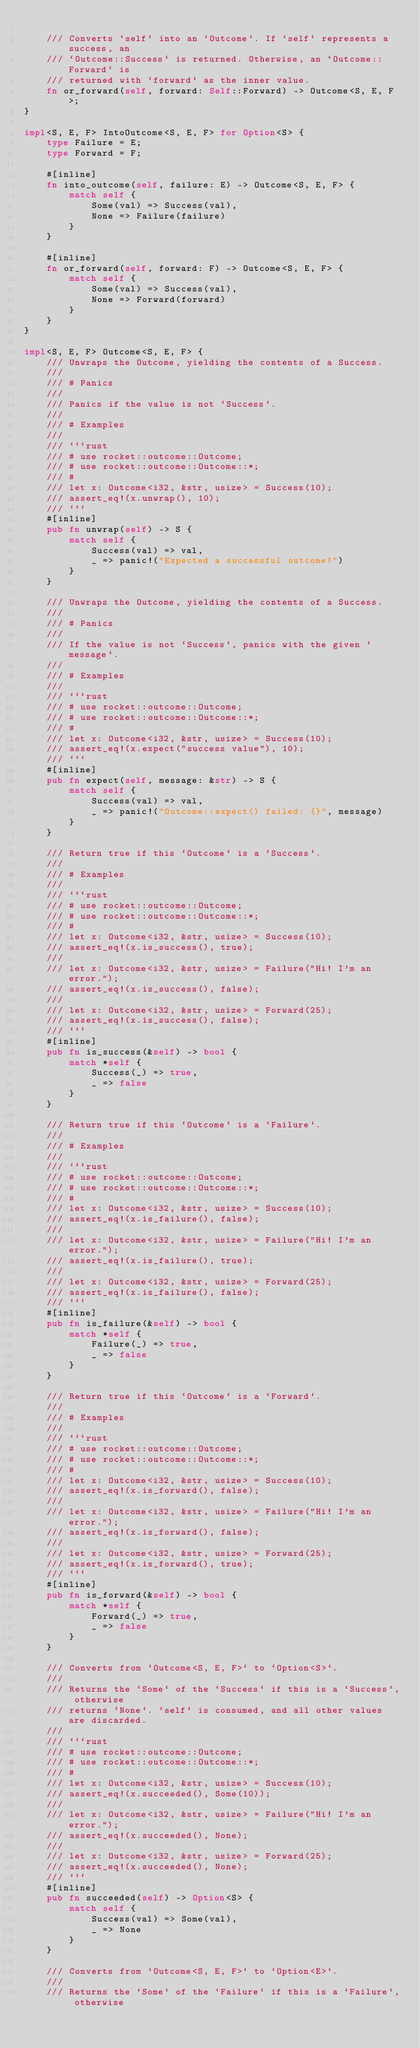Convert code to text. <code><loc_0><loc_0><loc_500><loc_500><_Rust_>
    /// Converts `self` into an `Outcome`. If `self` represents a success, an
    /// `Outcome::Success` is returned. Otherwise, an `Outcome::Forward` is
    /// returned with `forward` as the inner value.
    fn or_forward(self, forward: Self::Forward) -> Outcome<S, E, F>;
}

impl<S, E, F> IntoOutcome<S, E, F> for Option<S> {
    type Failure = E;
    type Forward = F;

    #[inline]
    fn into_outcome(self, failure: E) -> Outcome<S, E, F> {
        match self {
            Some(val) => Success(val),
            None => Failure(failure)
        }
    }

    #[inline]
    fn or_forward(self, forward: F) -> Outcome<S, E, F> {
        match self {
            Some(val) => Success(val),
            None => Forward(forward)
        }
    }
}

impl<S, E, F> Outcome<S, E, F> {
    /// Unwraps the Outcome, yielding the contents of a Success.
    ///
    /// # Panics
    ///
    /// Panics if the value is not `Success`.
    ///
    /// # Examples
    ///
    /// ```rust
    /// # use rocket::outcome::Outcome;
    /// # use rocket::outcome::Outcome::*;
    /// #
    /// let x: Outcome<i32, &str, usize> = Success(10);
    /// assert_eq!(x.unwrap(), 10);
    /// ```
    #[inline]
    pub fn unwrap(self) -> S {
        match self {
            Success(val) => val,
            _ => panic!("Expected a successful outcome!")
        }
    }

    /// Unwraps the Outcome, yielding the contents of a Success.
    ///
    /// # Panics
    ///
    /// If the value is not `Success`, panics with the given `message`.
    ///
    /// # Examples
    ///
    /// ```rust
    /// # use rocket::outcome::Outcome;
    /// # use rocket::outcome::Outcome::*;
    /// #
    /// let x: Outcome<i32, &str, usize> = Success(10);
    /// assert_eq!(x.expect("success value"), 10);
    /// ```
    #[inline]
    pub fn expect(self, message: &str) -> S {
        match self {
            Success(val) => val,
            _ => panic!("Outcome::expect() failed: {}", message)
        }
    }

    /// Return true if this `Outcome` is a `Success`.
    ///
    /// # Examples
    ///
    /// ```rust
    /// # use rocket::outcome::Outcome;
    /// # use rocket::outcome::Outcome::*;
    /// #
    /// let x: Outcome<i32, &str, usize> = Success(10);
    /// assert_eq!(x.is_success(), true);
    ///
    /// let x: Outcome<i32, &str, usize> = Failure("Hi! I'm an error.");
    /// assert_eq!(x.is_success(), false);
    ///
    /// let x: Outcome<i32, &str, usize> = Forward(25);
    /// assert_eq!(x.is_success(), false);
    /// ```
    #[inline]
    pub fn is_success(&self) -> bool {
        match *self {
            Success(_) => true,
            _ => false
        }
    }

    /// Return true if this `Outcome` is a `Failure`.
    ///
    /// # Examples
    ///
    /// ```rust
    /// # use rocket::outcome::Outcome;
    /// # use rocket::outcome::Outcome::*;
    /// #
    /// let x: Outcome<i32, &str, usize> = Success(10);
    /// assert_eq!(x.is_failure(), false);
    ///
    /// let x: Outcome<i32, &str, usize> = Failure("Hi! I'm an error.");
    /// assert_eq!(x.is_failure(), true);
    ///
    /// let x: Outcome<i32, &str, usize> = Forward(25);
    /// assert_eq!(x.is_failure(), false);
    /// ```
    #[inline]
    pub fn is_failure(&self) -> bool {
        match *self {
            Failure(_) => true,
            _ => false
        }
    }

    /// Return true if this `Outcome` is a `Forward`.
    ///
    /// # Examples
    ///
    /// ```rust
    /// # use rocket::outcome::Outcome;
    /// # use rocket::outcome::Outcome::*;
    /// #
    /// let x: Outcome<i32, &str, usize> = Success(10);
    /// assert_eq!(x.is_forward(), false);
    ///
    /// let x: Outcome<i32, &str, usize> = Failure("Hi! I'm an error.");
    /// assert_eq!(x.is_forward(), false);
    ///
    /// let x: Outcome<i32, &str, usize> = Forward(25);
    /// assert_eq!(x.is_forward(), true);
    /// ```
    #[inline]
    pub fn is_forward(&self) -> bool {
        match *self {
            Forward(_) => true,
            _ => false
        }
    }

    /// Converts from `Outcome<S, E, F>` to `Option<S>`.
    ///
    /// Returns the `Some` of the `Success` if this is a `Success`, otherwise
    /// returns `None`. `self` is consumed, and all other values are discarded.
    ///
    /// ```rust
    /// # use rocket::outcome::Outcome;
    /// # use rocket::outcome::Outcome::*;
    /// #
    /// let x: Outcome<i32, &str, usize> = Success(10);
    /// assert_eq!(x.succeeded(), Some(10));
    ///
    /// let x: Outcome<i32, &str, usize> = Failure("Hi! I'm an error.");
    /// assert_eq!(x.succeeded(), None);
    ///
    /// let x: Outcome<i32, &str, usize> = Forward(25);
    /// assert_eq!(x.succeeded(), None);
    /// ```
    #[inline]
    pub fn succeeded(self) -> Option<S> {
        match self {
            Success(val) => Some(val),
            _ => None
        }
    }

    /// Converts from `Outcome<S, E, F>` to `Option<E>`.
    ///
    /// Returns the `Some` of the `Failure` if this is a `Failure`, otherwise</code> 